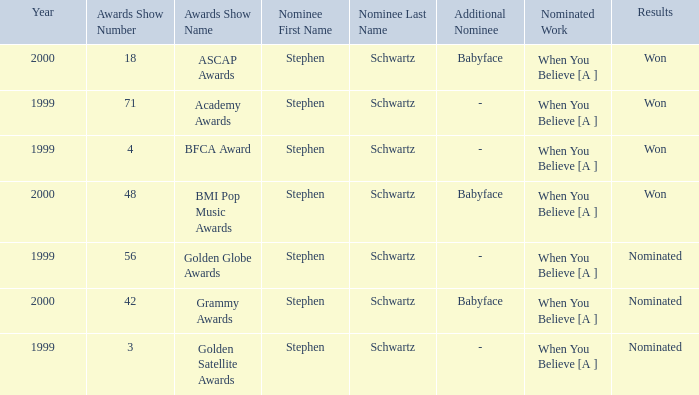Write the full table. {'header': ['Year', 'Awards Show Number', 'Awards Show Name', 'Nominee First Name', 'Nominee Last Name', 'Additional Nominee', 'Nominated Work', 'Results'], 'rows': [['2000', '18', 'ASCAP Awards', 'Stephen', 'Schwartz', 'Babyface', 'When You Believe [A ]', 'Won'], ['1999', '71', 'Academy Awards', 'Stephen', 'Schwartz', '-', 'When You Believe [A ]', 'Won'], ['1999', '4', 'BFCA Award', 'Stephen', 'Schwartz', '-', 'When You Believe [A ]', 'Won'], ['2000', '48', 'BMI Pop Music Awards', 'Stephen', 'Schwartz', 'Babyface', 'When You Believe [A ]', 'Won'], ['1999', '56', 'Golden Globe Awards', 'Stephen', 'Schwartz', '-', 'When You Believe [A ]', 'Nominated'], ['2000', '42', 'Grammy Awards', 'Stephen', 'Schwartz', 'Babyface', 'When You Believe [A ]', 'Nominated'], ['1999', '3', 'Golden Satellite Awards', 'Stephen', 'Schwartz', '-', 'When You Believe [A ]', 'Nominated']]} Which work, nominated in 2000, emerged as the winner? When You Believe [A ], When You Believe [A ]. 